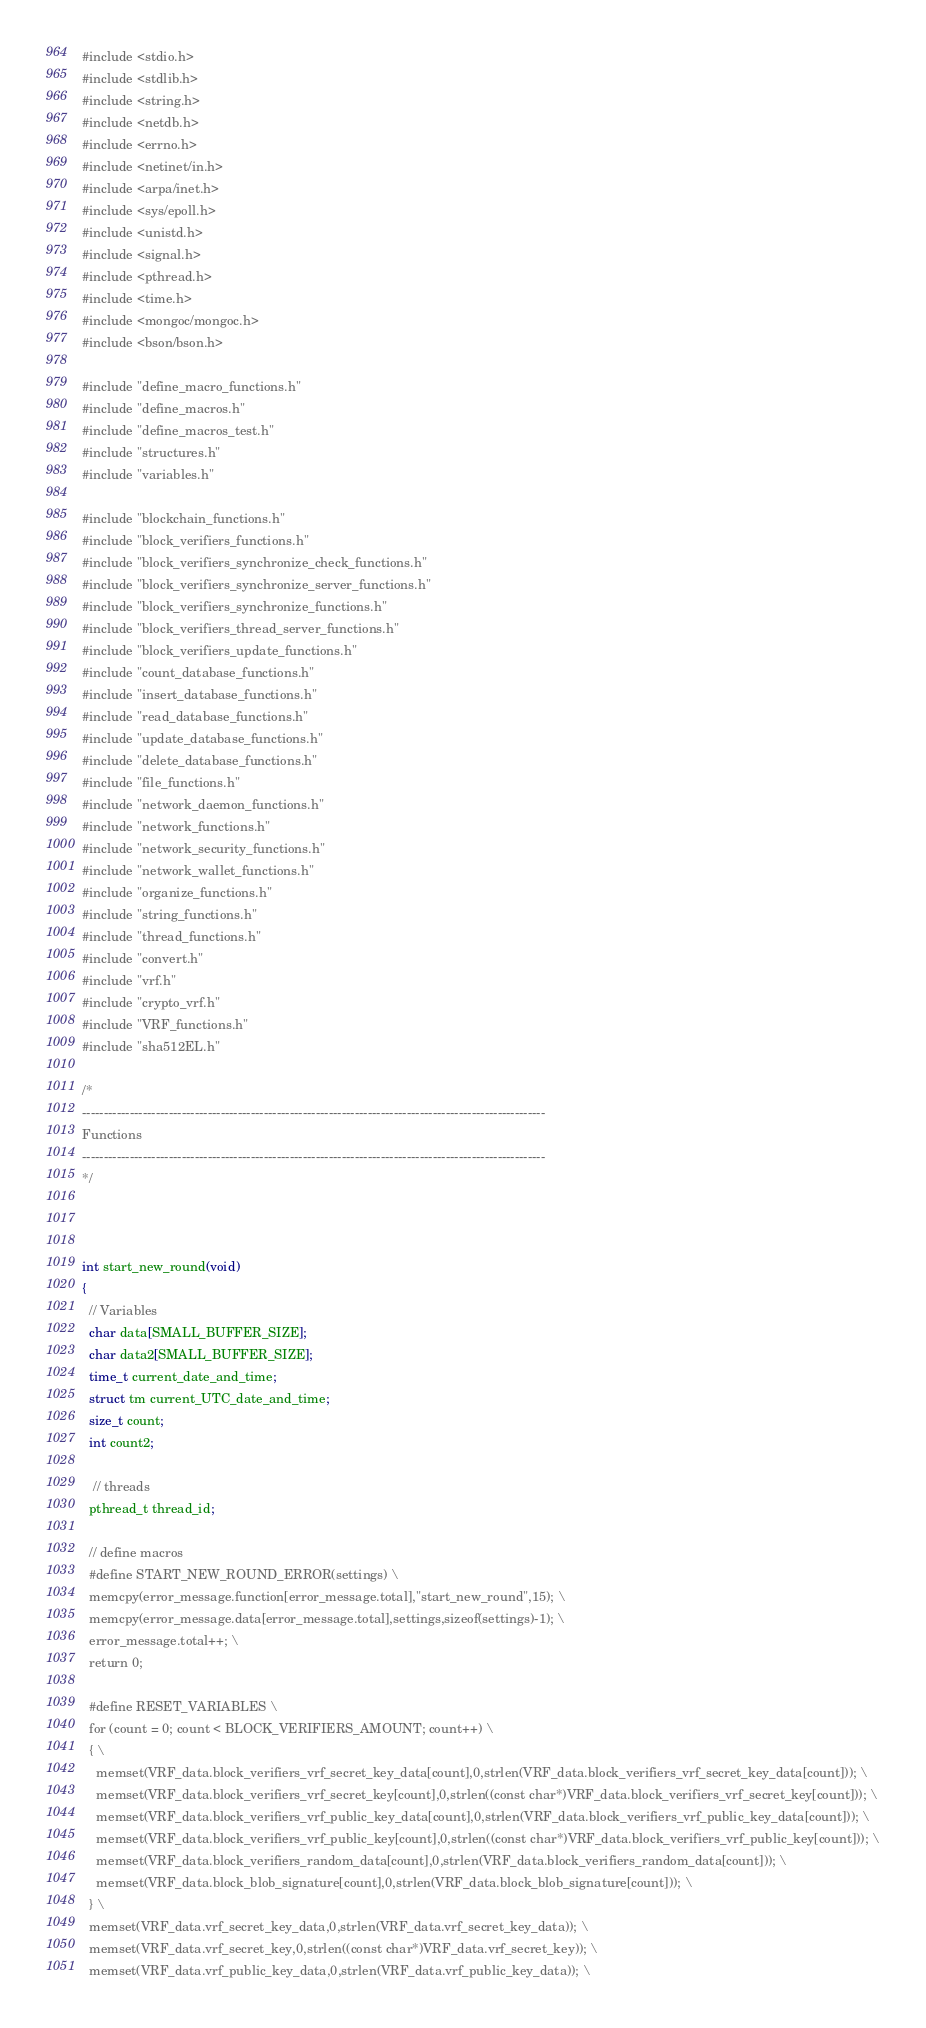<code> <loc_0><loc_0><loc_500><loc_500><_C_>#include <stdio.h>
#include <stdlib.h>
#include <string.h>
#include <netdb.h> 
#include <errno.h>
#include <netinet/in.h>
#include <arpa/inet.h>
#include <sys/epoll.h>
#include <unistd.h>
#include <signal.h>
#include <pthread.h>
#include <time.h>
#include <mongoc/mongoc.h>
#include <bson/bson.h>

#include "define_macro_functions.h"
#include "define_macros.h"
#include "define_macros_test.h"
#include "structures.h"
#include "variables.h"

#include "blockchain_functions.h"
#include "block_verifiers_functions.h"
#include "block_verifiers_synchronize_check_functions.h"
#include "block_verifiers_synchronize_server_functions.h"
#include "block_verifiers_synchronize_functions.h"
#include "block_verifiers_thread_server_functions.h"
#include "block_verifiers_update_functions.h"
#include "count_database_functions.h"
#include "insert_database_functions.h"
#include "read_database_functions.h"
#include "update_database_functions.h"
#include "delete_database_functions.h"
#include "file_functions.h"
#include "network_daemon_functions.h"
#include "network_functions.h"
#include "network_security_functions.h"
#include "network_wallet_functions.h"
#include "organize_functions.h"
#include "string_functions.h"
#include "thread_functions.h"
#include "convert.h"
#include "vrf.h"
#include "crypto_vrf.h"
#include "VRF_functions.h"
#include "sha512EL.h"

/*
-----------------------------------------------------------------------------------------------------------
Functions
-----------------------------------------------------------------------------------------------------------
*/



int start_new_round(void)
{
  // Variables
  char data[SMALL_BUFFER_SIZE];
  char data2[SMALL_BUFFER_SIZE];
  time_t current_date_and_time;
  struct tm current_UTC_date_and_time;
  size_t count;
  int count2;

   // threads
  pthread_t thread_id;

  // define macros
  #define START_NEW_ROUND_ERROR(settings) \
  memcpy(error_message.function[error_message.total],"start_new_round",15); \
  memcpy(error_message.data[error_message.total],settings,sizeof(settings)-1); \
  error_message.total++; \
  return 0;

  #define RESET_VARIABLES \
  for (count = 0; count < BLOCK_VERIFIERS_AMOUNT; count++) \
  { \
    memset(VRF_data.block_verifiers_vrf_secret_key_data[count],0,strlen(VRF_data.block_verifiers_vrf_secret_key_data[count])); \
    memset(VRF_data.block_verifiers_vrf_secret_key[count],0,strlen((const char*)VRF_data.block_verifiers_vrf_secret_key[count])); \
    memset(VRF_data.block_verifiers_vrf_public_key_data[count],0,strlen(VRF_data.block_verifiers_vrf_public_key_data[count])); \
    memset(VRF_data.block_verifiers_vrf_public_key[count],0,strlen((const char*)VRF_data.block_verifiers_vrf_public_key[count])); \
    memset(VRF_data.block_verifiers_random_data[count],0,strlen(VRF_data.block_verifiers_random_data[count])); \
    memset(VRF_data.block_blob_signature[count],0,strlen(VRF_data.block_blob_signature[count])); \
  } \
  memset(VRF_data.vrf_secret_key_data,0,strlen(VRF_data.vrf_secret_key_data)); \
  memset(VRF_data.vrf_secret_key,0,strlen((const char*)VRF_data.vrf_secret_key)); \
  memset(VRF_data.vrf_public_key_data,0,strlen(VRF_data.vrf_public_key_data)); \</code> 